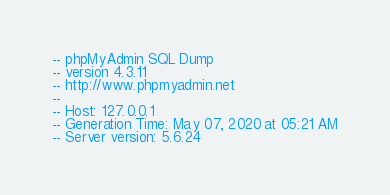Convert code to text. <code><loc_0><loc_0><loc_500><loc_500><_SQL_>-- phpMyAdmin SQL Dump
-- version 4.3.11
-- http://www.phpmyadmin.net
--
-- Host: 127.0.0.1
-- Generation Time: May 07, 2020 at 05:21 AM
-- Server version: 5.6.24</code> 